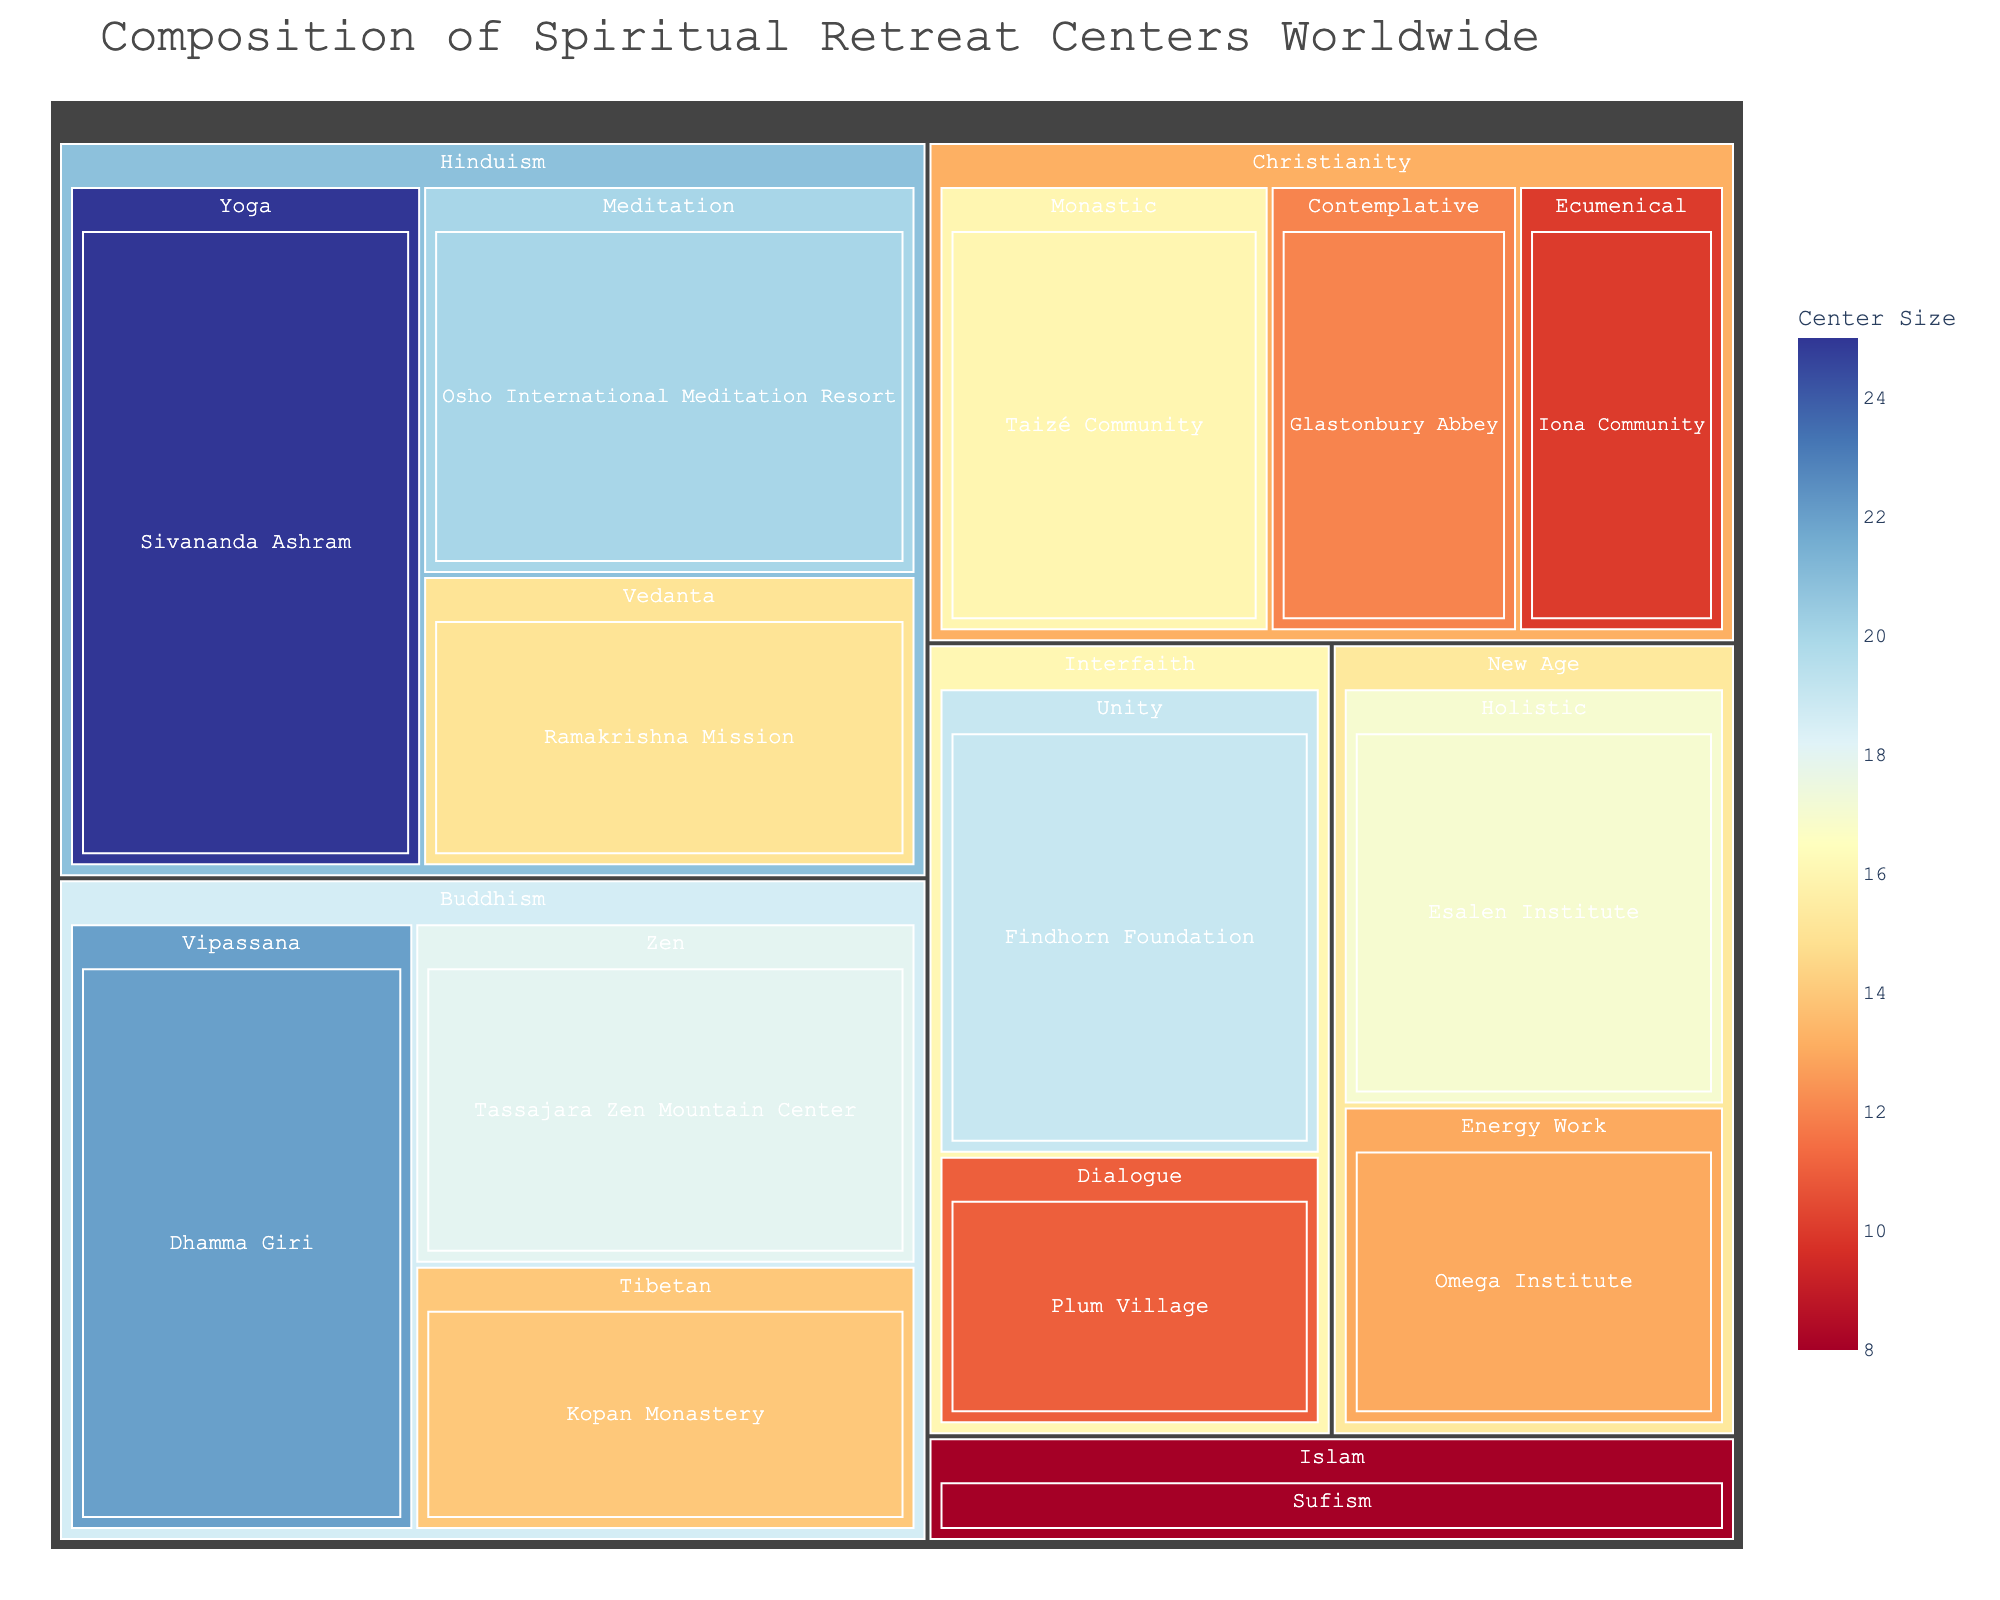What's the title of the treemap? The title is prominently displayed at the top of the treemap and is usually larger in font size compared to other text. The title is "Composition of Spiritual Retreat Centers Worldwide."
Answer: Composition of Spiritual Retreat Centers Worldwide Which center has the greatest size in the Hinduism category? In the treemap, the size of each segment corresponds to its value. The largest segment under the Hinduism category can be identified by looking at the area covered. "Sivananda Ashram" has the greatest size, with a value of 25.
Answer: Sivananda Ashram What is the combined value of all Buddhism focused retreat centers? To answer this, we sum the values of all centers under the Buddhism category: Tassajara Zen Mountain Center (18), Dhamma Giri (22), and Kopan Monastery (14). So, 18 + 22 + 14 = 54.
Answer: 54 Which category has the highest number of retreat centers? Count the number of centers in each category by examining the subdivisions within each category. Hinduism, Buddhism, and Christianity each have 3 centers, but comparing the number of divisions visually shows all three categories have the highest number of centers.
Answer: Hinduism, Buddhism, and Christianity How does the size of the Findhorn Foundation compare to the size of the Omega Institute? Compare the values of the centers: Findhorn Foundation has a value of 19, and Omega Institute has a value of 13. Since 19 is greater than 13, the Findhorn Foundation is larger.
Answer: Findhorn Foundation is larger What is the average value of the centers in the Interfaith category? The values of the centers in the Interfaith category are Findhorn Foundation (19) and Plum Village (11). The average is calculated as (19 + 11) / 2 = 15.
Answer: 15 Which center under the Christianity category has the smallest value? Examine the values of the centers in the Christianity category: Glastonbury Abbey (12), Taizé Community (16), and Iona Community (10). The smallest value is 10, which belongs to Iona Community.
Answer: Iona Community What is the color scheme used in the treemap? The treemap uses a diverging color scheme that ranges from red to blue, typically showing values on a gradient scale for easy differentiation. This is evident from the color variation between the segments.
Answer: Red to Blue What is the sum of the values of the Yoga and Meditation focused centers within the Hinduism category? Add the values of the Sivananda Ashram (25) and Osho International Meditation Resort (20). So, 25 + 20 = 45.
Answer: 45 How many centers focus on Sufism and which category do they belong to? Observe the treemap and identify the specific focus. "Dergah of Shaikh Nazim" focuses on Sufism, and it belongs to the Islam category.
Answer: One center, Islam 